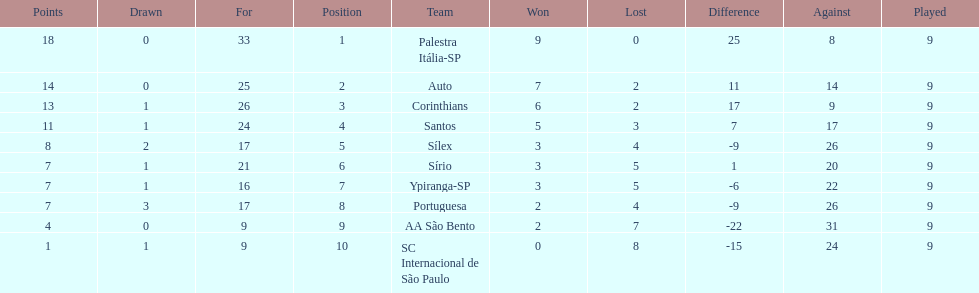In 1926 brazilian football, how many teams scored above 10 points in the season? 4. 